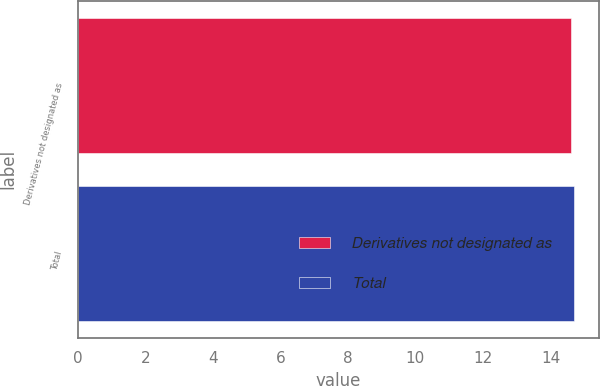<chart> <loc_0><loc_0><loc_500><loc_500><bar_chart><fcel>Derivatives not designated as<fcel>Total<nl><fcel>14.6<fcel>14.7<nl></chart> 